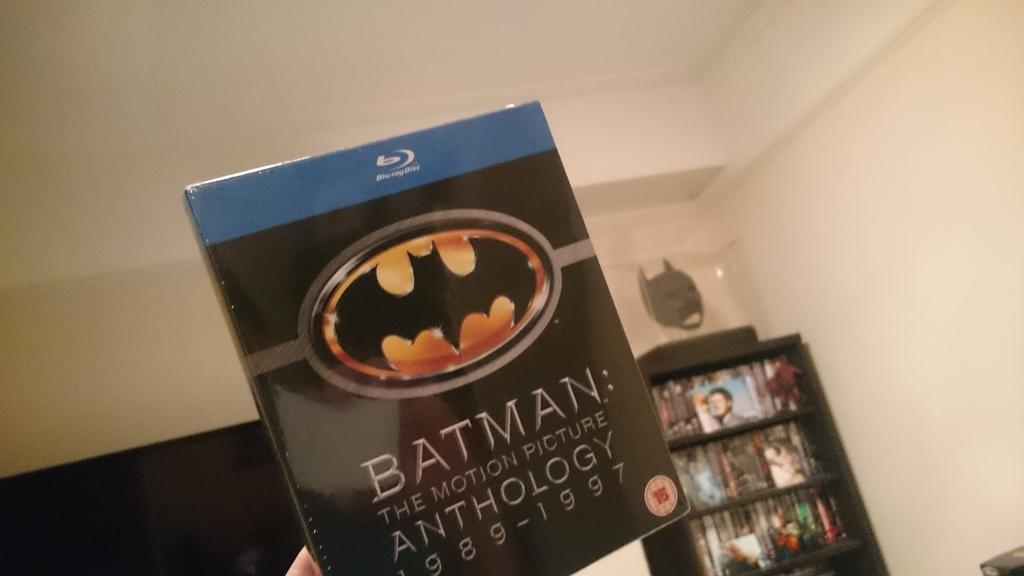<image>
Give a short and clear explanation of the subsequent image. A person holding Batman: The Motion Picture 1989-1997 movie. 